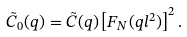Convert formula to latex. <formula><loc_0><loc_0><loc_500><loc_500>\tilde { C } _ { 0 } ( q ) = \tilde { C } ( q ) \left [ F _ { N } ( q l ^ { 2 } ) \right ] ^ { 2 } .</formula> 